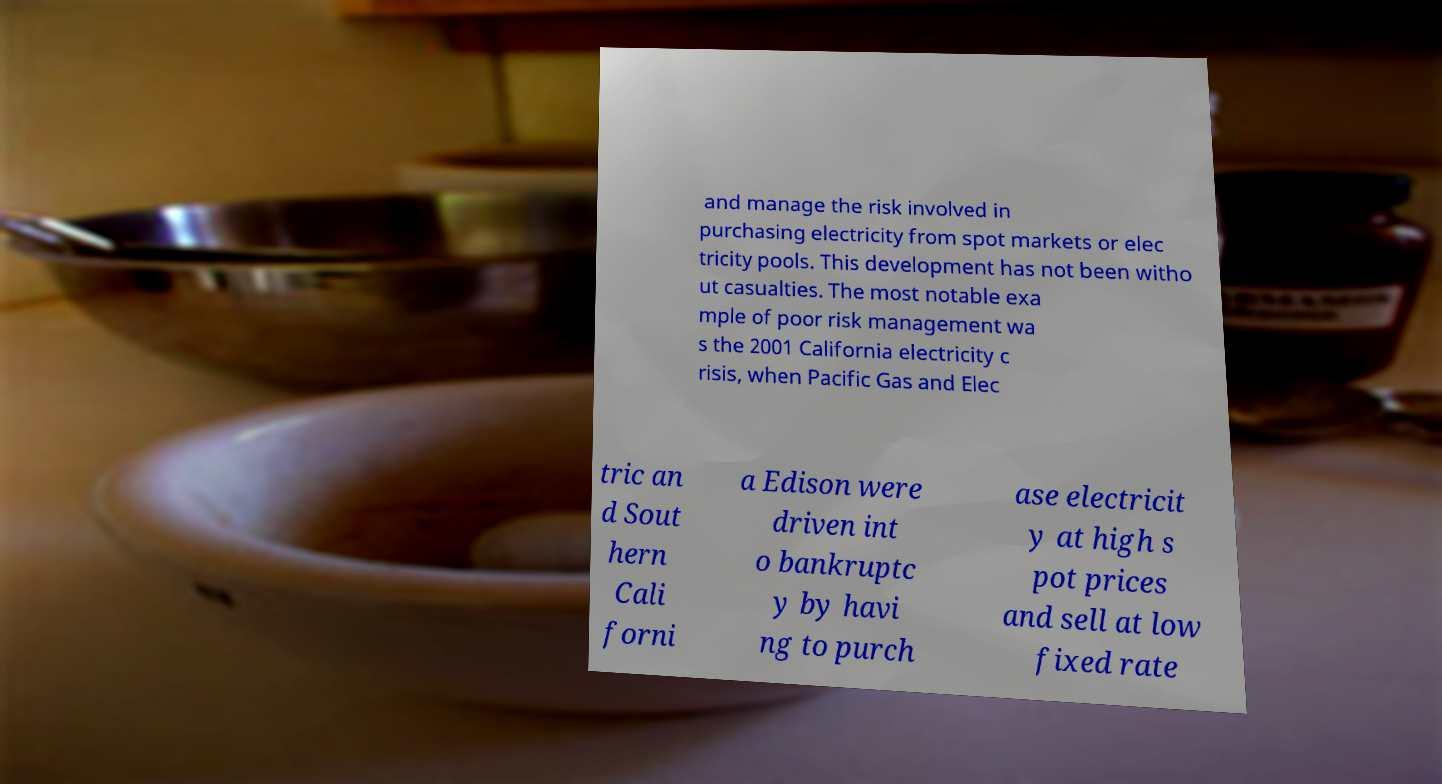Please read and relay the text visible in this image. What does it say? and manage the risk involved in purchasing electricity from spot markets or elec tricity pools. This development has not been witho ut casualties. The most notable exa mple of poor risk management wa s the 2001 California electricity c risis, when Pacific Gas and Elec tric an d Sout hern Cali forni a Edison were driven int o bankruptc y by havi ng to purch ase electricit y at high s pot prices and sell at low fixed rate 